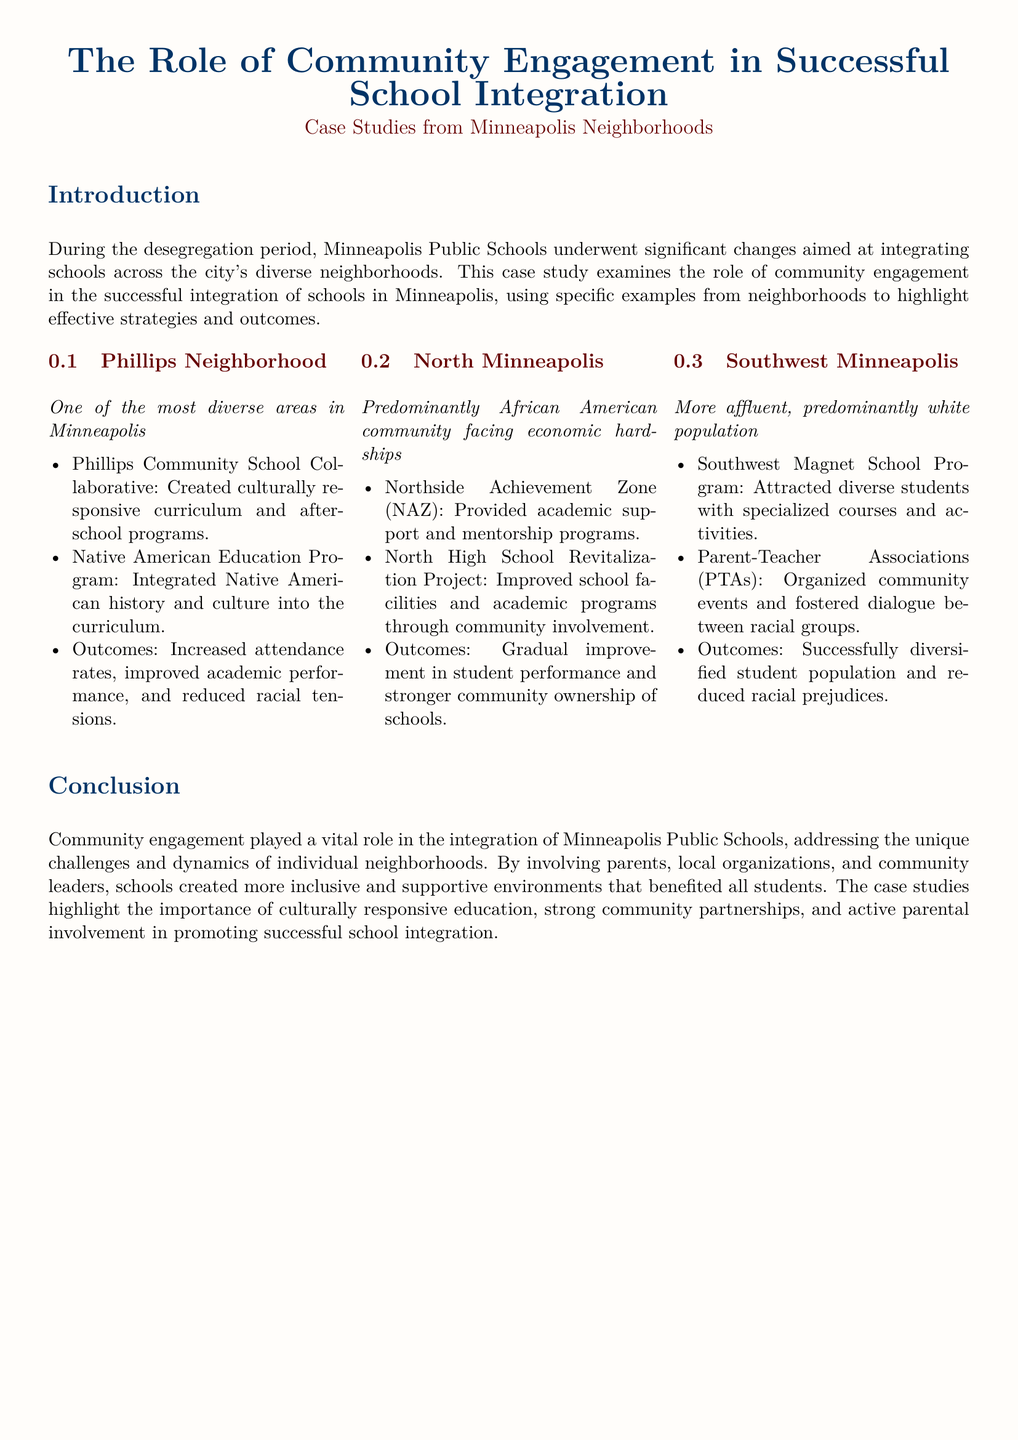What is the focus of the case study? The case study examines the role of community engagement in the successful integration of schools in Minneapolis.
Answer: Community engagement Which neighborhood is described as one of the most diverse areas in Minneapolis? It is specified in the case study that Phillips Neighborhood is one of the most diverse areas.
Answer: Phillips Neighborhood What program was implemented in North Minneapolis to provide academic support? The document mentions the Northside Achievement Zone (NAZ) as the program for academic support.
Answer: Northside Achievement Zone What was an outcome of the Phillips Community School Collaborative? The outcomes noted include increased attendance rates and improved academic performance.
Answer: Increased attendance rates What initiative was taken in Southwest Minneapolis to attract diverse students? The Southwest Magnet School Program was introduced to attract diverse students.
Answer: Southwest Magnet School Program Which community initiative aimed to integrate Native American history into the curriculum? The case study mentions the Native American Education Program for this purpose.
Answer: Native American Education Program What was the main focus of the North High School Revitalization Project? The project focused on improving school facilities and academic programs through community involvement.
Answer: Improving school facilities What type of organizations played a critical role in community engagement, as noted in the conclusion? The conclusion specifies that local organizations played an important role in community engagement.
Answer: Local organizations What was one outcome of parental involvement in schools according to the case study? The document states that parental involvement helped create more inclusive and supportive environments.
Answer: More inclusive environments 